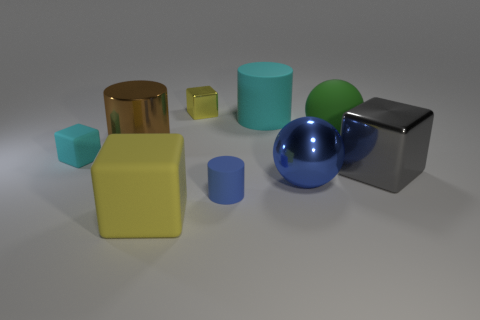Are there more large green things left of the big matte block than big blue balls that are on the left side of the big cyan matte cylinder?
Your answer should be compact. No. The large gray object that is made of the same material as the brown cylinder is what shape?
Ensure brevity in your answer.  Cube. How many other objects are the same shape as the large brown metallic thing?
Your answer should be compact. 2. What shape is the cyan rubber thing that is to the right of the tiny cyan rubber cube?
Offer a terse response. Cylinder. The large metallic block has what color?
Give a very brief answer. Gray. What number of other objects are the same size as the blue rubber cylinder?
Keep it short and to the point. 2. What is the material of the yellow cube that is in front of the tiny cube to the left of the large yellow cube?
Offer a terse response. Rubber. Does the green matte thing have the same size as the sphere that is in front of the large green rubber thing?
Your response must be concise. Yes. Are there any matte spheres of the same color as the tiny metallic thing?
Offer a terse response. No. What number of small objects are cyan matte objects or gray metal cylinders?
Keep it short and to the point. 1. 